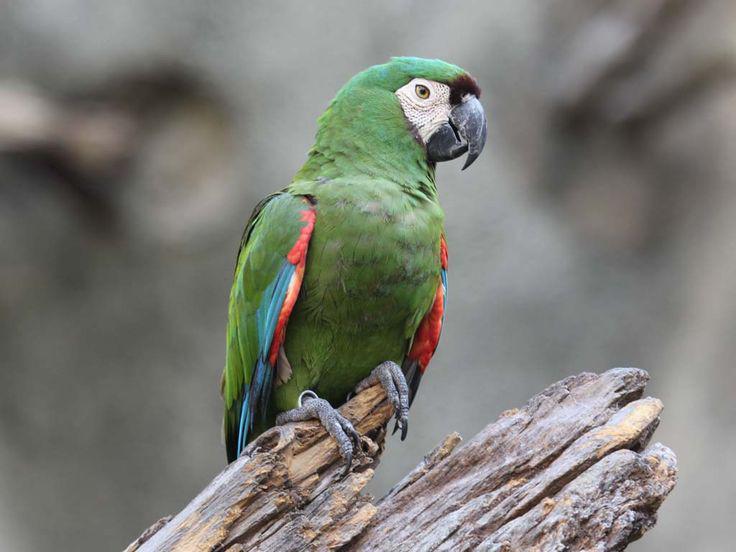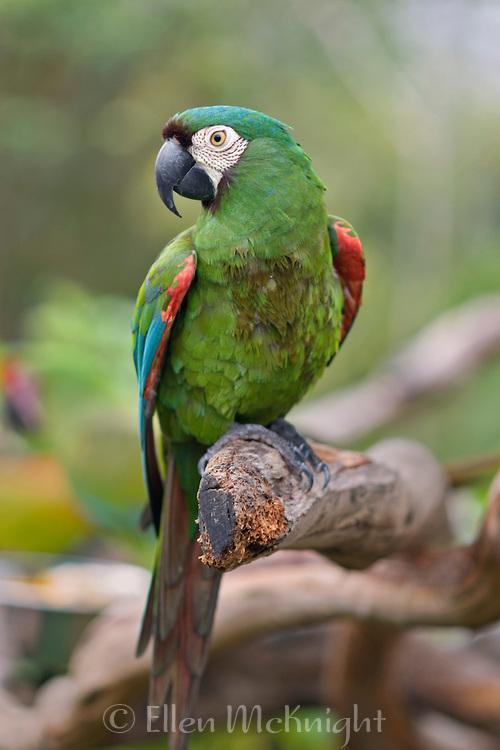The first image is the image on the left, the second image is the image on the right. Analyze the images presented: Is the assertion "The bird in the right image is using a tree branch for its perch." valid? Answer yes or no. Yes. The first image is the image on the left, the second image is the image on the right. Assess this claim about the two images: "In each image, the parrot faces rightward.". Correct or not? Answer yes or no. No. 